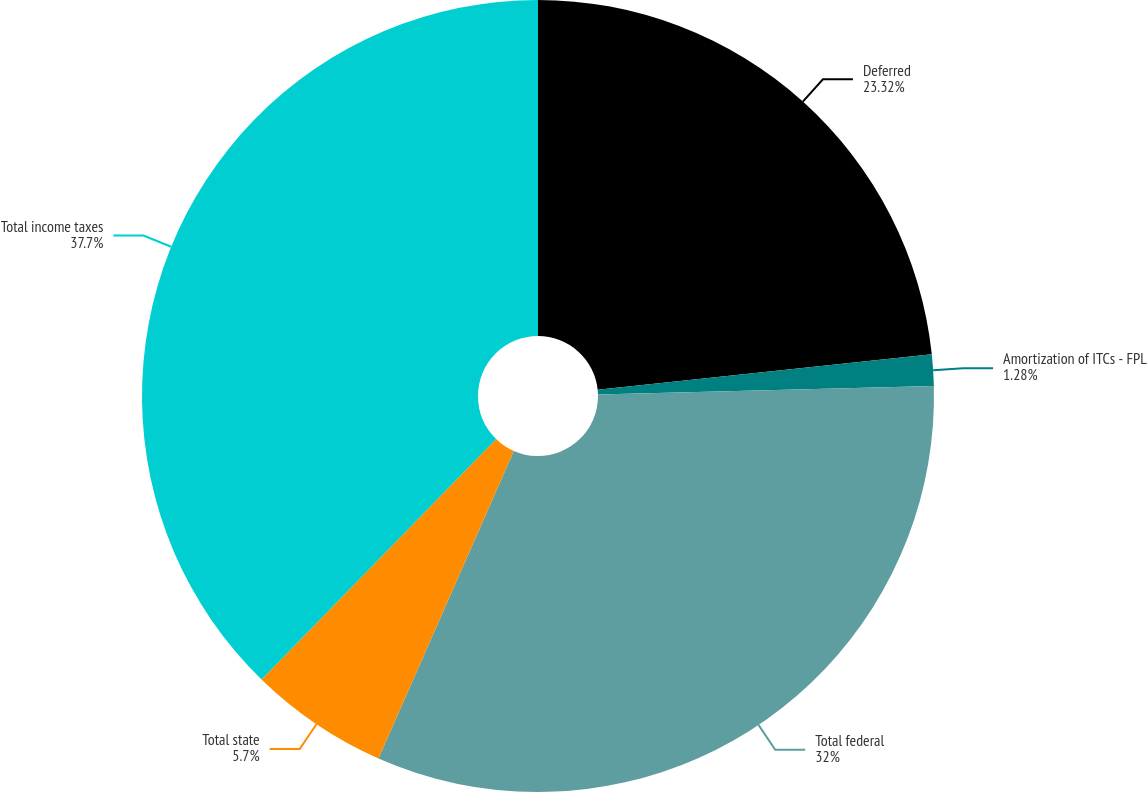<chart> <loc_0><loc_0><loc_500><loc_500><pie_chart><fcel>Deferred<fcel>Amortization of ITCs - FPL<fcel>Total federal<fcel>Total state<fcel>Total income taxes<nl><fcel>23.32%<fcel>1.28%<fcel>32.0%<fcel>5.7%<fcel>37.7%<nl></chart> 